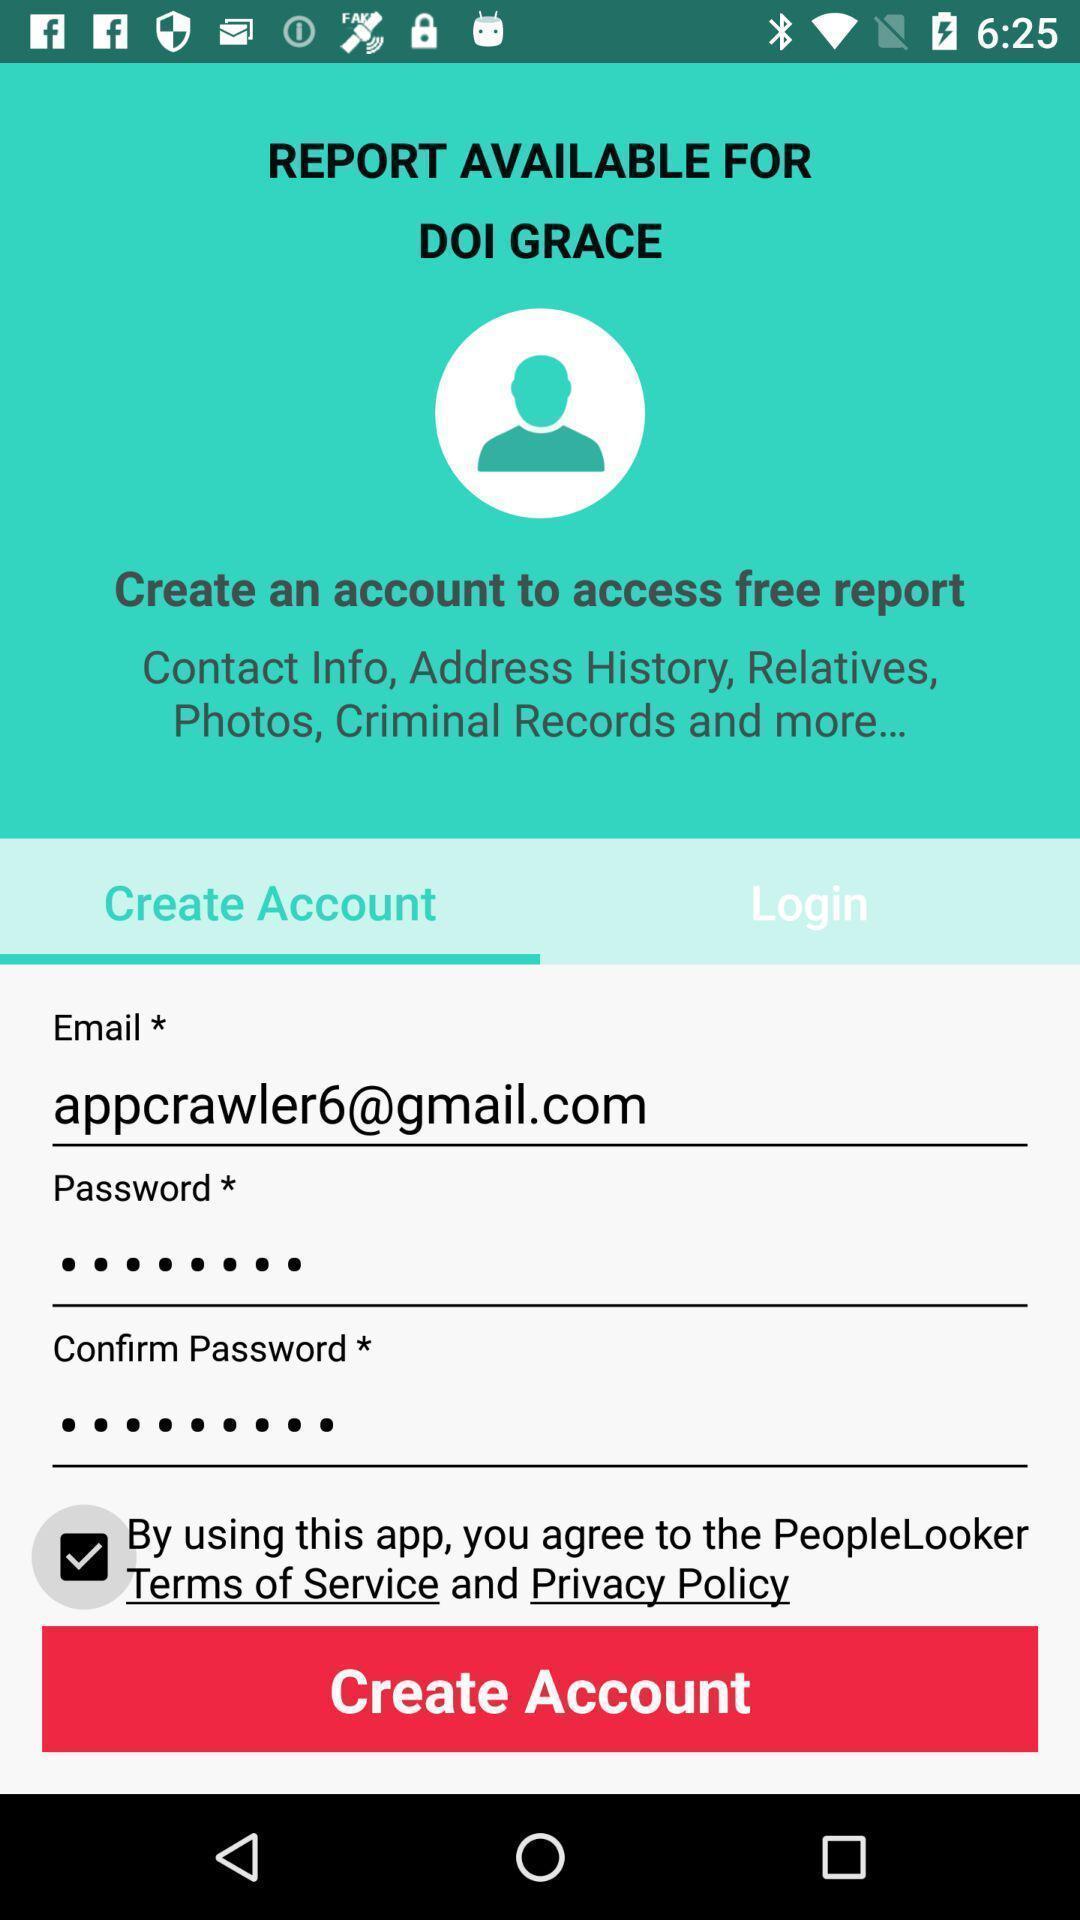What details can you identify in this image? Sign in page of social app to create. 